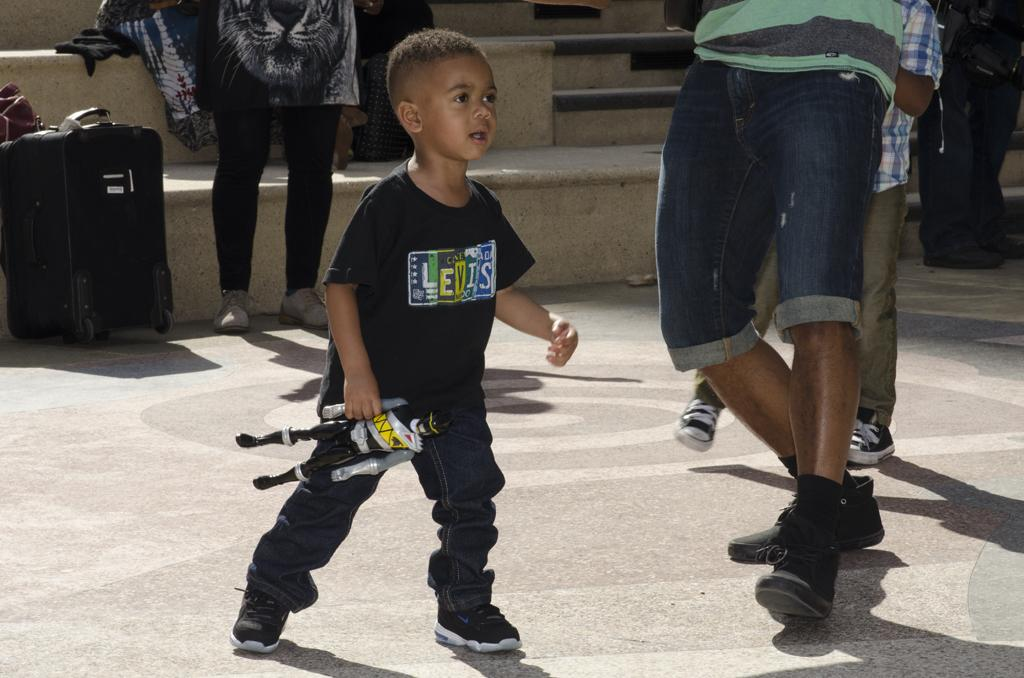What is the main subject in the center of the image? There is a boy in the center of the image. What is the boy holding in the image? The boy is holding a toy. Can you describe the people surrounding the boy? There are people standing around the boy. What type of transportation is present in the image? A trolley is present in the image. What architectural feature can be seen in the background? There is a staircase in the image. What other objects are visible around the boy? There are additional objects around the boy. What is the boy's desire for the steam coming from the trolley in the image? There is no steam coming from the trolley in the image, and therefore no desire related to steam can be attributed to the boy. 